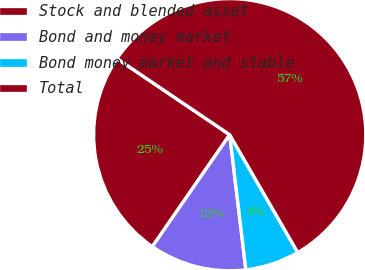Convert chart. <chart><loc_0><loc_0><loc_500><loc_500><pie_chart><fcel>Stock and blended asset<fcel>Bond and money market<fcel>Bond money market and stable<fcel>Total<nl><fcel>24.83%<fcel>11.52%<fcel>6.44%<fcel>57.2%<nl></chart> 